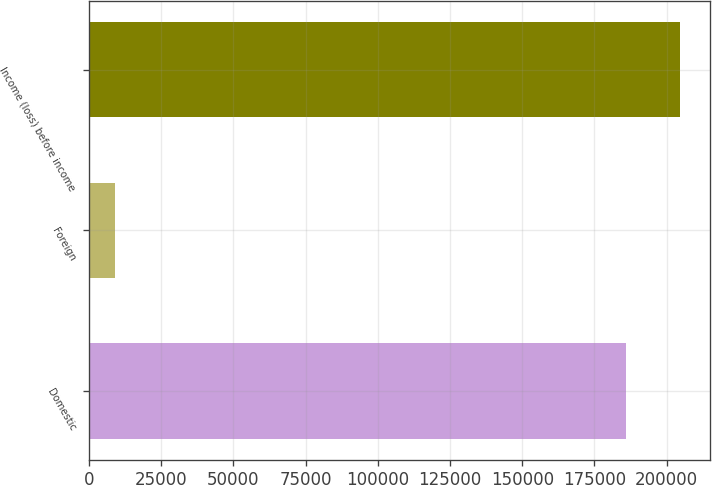Convert chart. <chart><loc_0><loc_0><loc_500><loc_500><bar_chart><fcel>Domestic<fcel>Foreign<fcel>Income (loss) before income<nl><fcel>186015<fcel>8924<fcel>204616<nl></chart> 